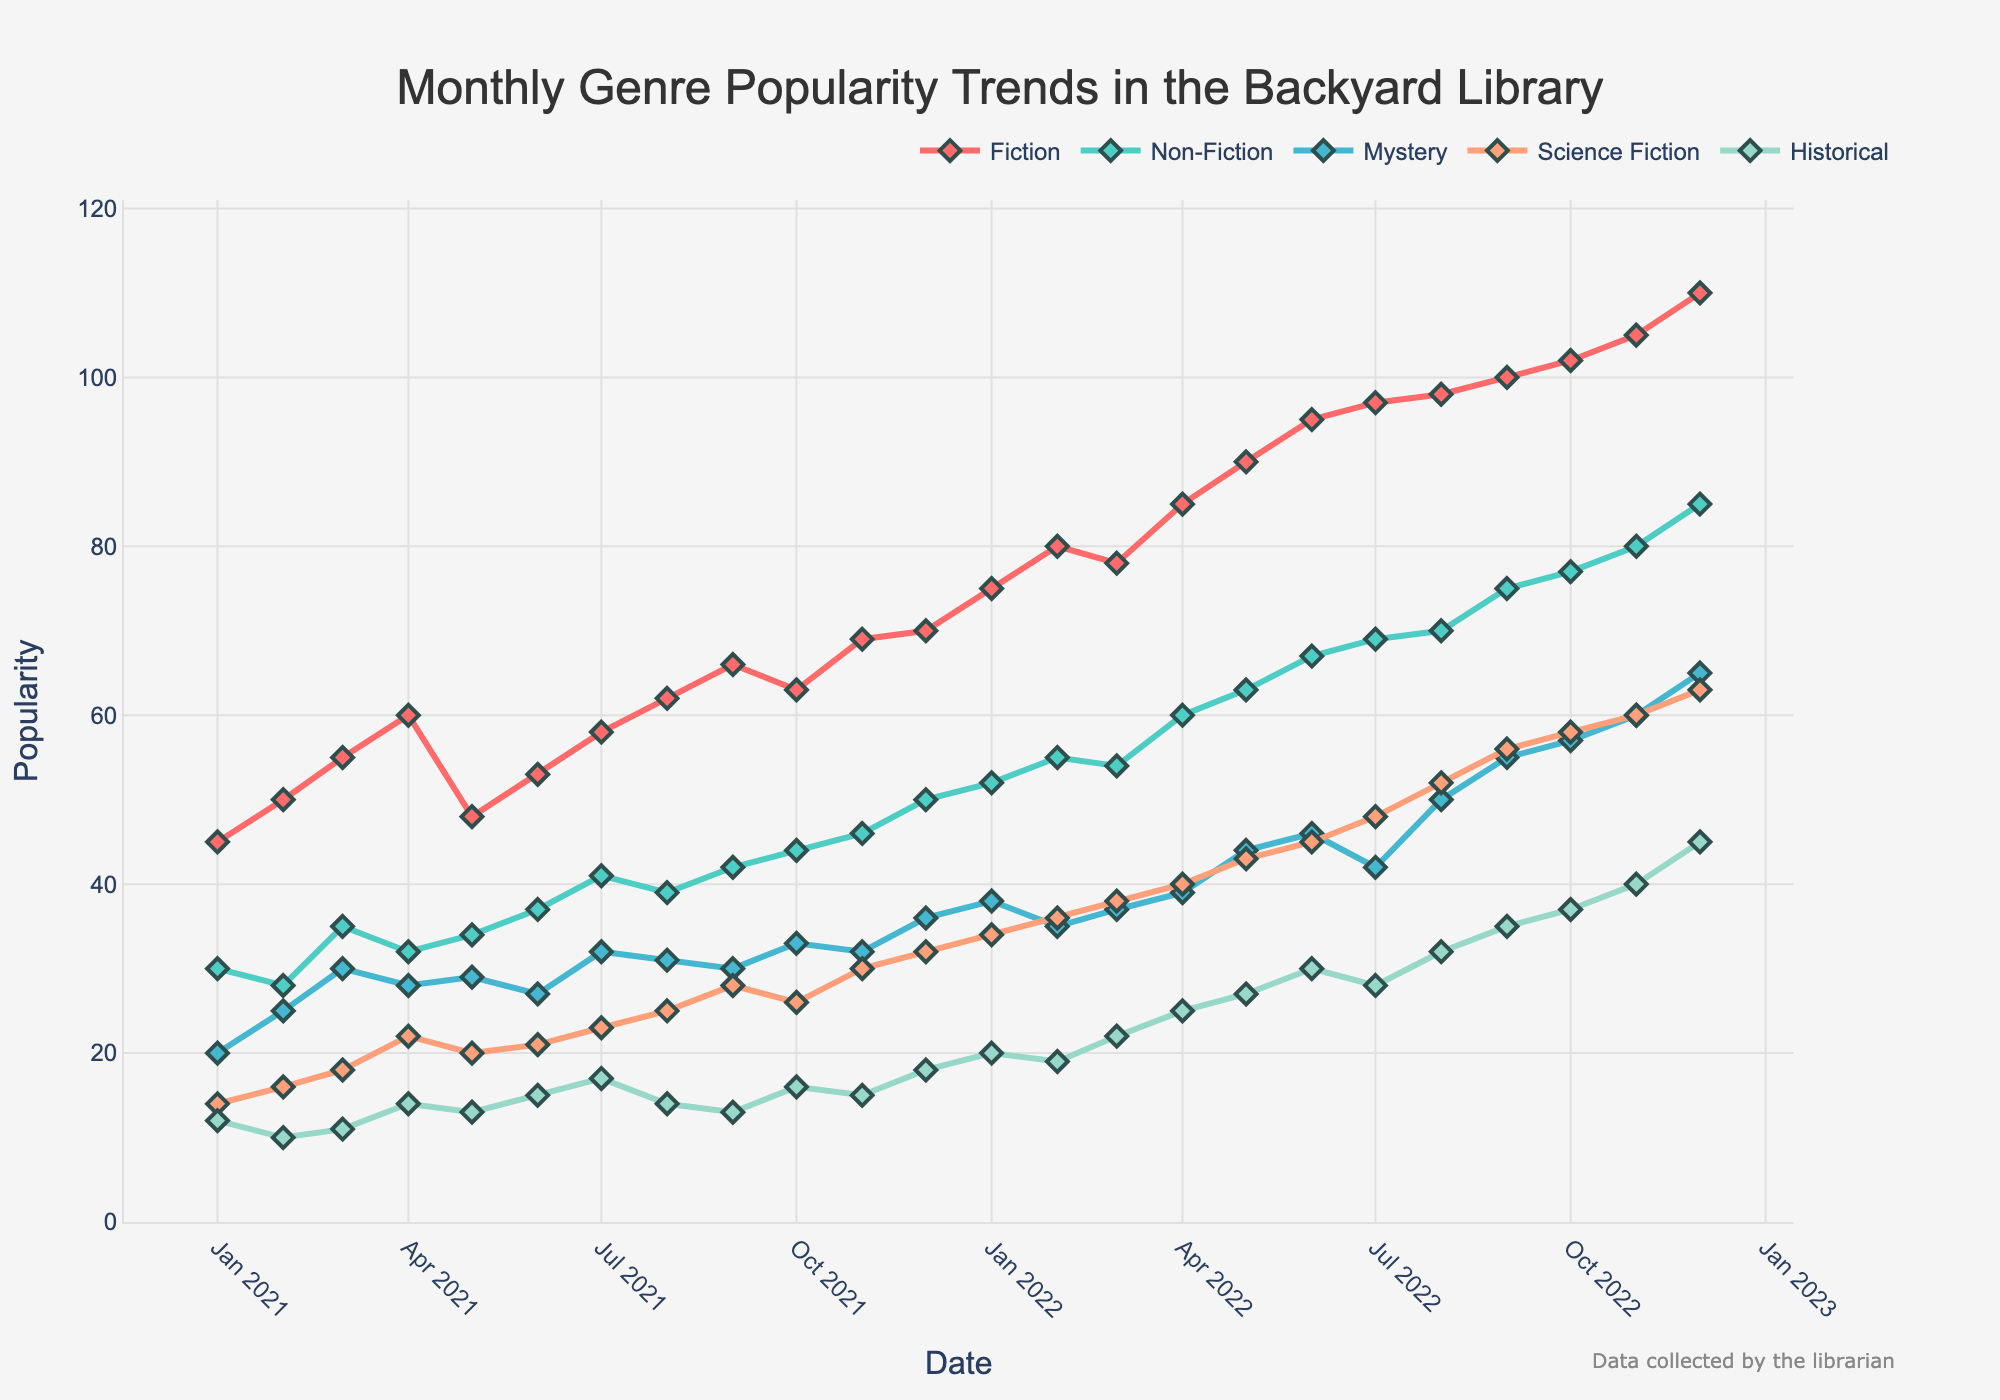What is the title of the figure? The title is usually found at the top center or top left of a figure in a larger font size. It provides a brief description of what the figure is about. Here, the title indicates the subject and scope of the data being illustrated.
Answer: Monthly Genre Popularity Trends in the Backyard Library How many different genres are shown in the plot? To determine the number of different genres shown, one should count the distinct lines or look at the legend, where each genre is named and color-coded.
Answer: Five Which genre had the highest popularity in December 2022? Locate the points corresponding to December 2022 on the x-axis, then look at the y-values of these points. The genre with the highest y-value is the one with the highest popularity.
Answer: Fiction By how much did the popularity of Science Fiction increase from January 2021 to December 2022? Identify the y-values for Science Fiction in January 2021 and December 2022. Subtract the January 2021 value from the December 2022 value. For January 2021, the popularity is 14, and for December 2022, it is 63, so the calculation is 63 - 14.
Answer: 49 Was Historical more popular in January 2022 or January 2021? Compare the y-values of the Historical genre for January 2021 and January 2022. The higher y-value corresponds to the more popular month. For January 2021, it is 12, and for January 2022, it is 20.
Answer: January 2022 Which month and year had the lowest popularity for the Mystery genre? Examine the y-values for each month and year for the Mystery genre. The lowest value corresponds to the month and year with the least popularity.
Answer: January 2021 What is the average popularity of Non-Fiction over the two-year period? Sum the y-values of Non-Fiction for all months and divide by the number of months (24). The sum is 50 + 28 + 35 + 32 + 34 + 37 + 41 + 39 + 42 + 44 + 46 + 50 + 52 + 55 + 54 + 60 + 63 + 67 + 69 + 70 + 75 + 77 + 80 + 85 = 1225. Then, 1225 / 24.
Answer: 51.04 Which genre showed the most consistent popularity trend over the two years? Examine the lines for all genres and identify which genre's line is the smoothest and least fluctuates over the period. This involves visually assessing the stability and consistency of the trend lines.
Answer: Non-Fiction During which month and year did Fiction first surpass a popularity of 100? Locate the point where the Fiction line crosses the y-value of 100 and identify the corresponding month and year.
Answer: October 2022 